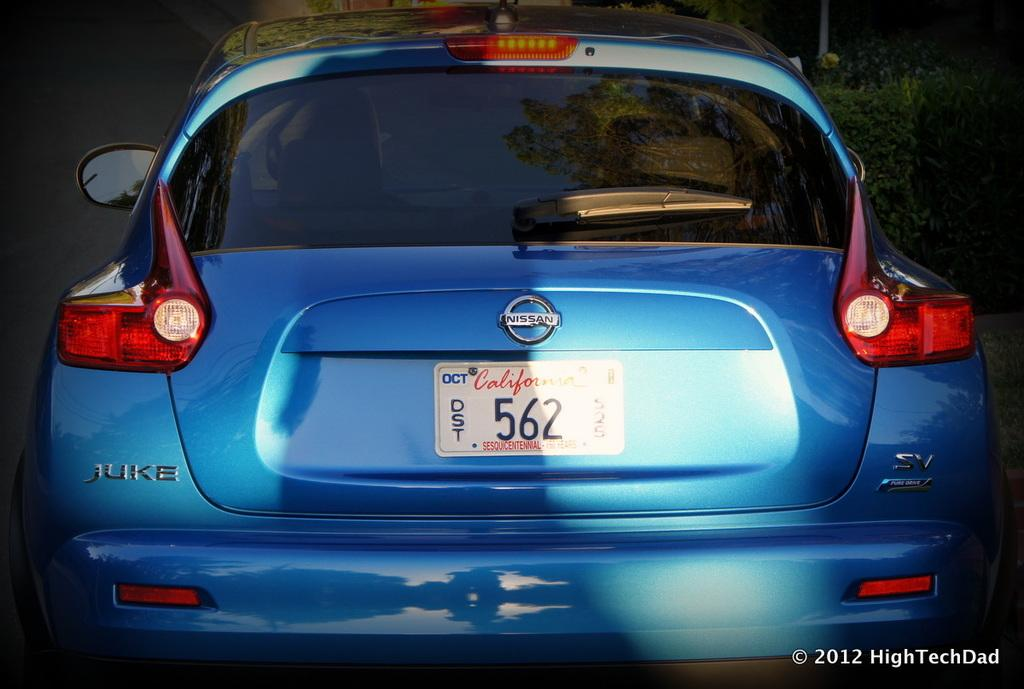<image>
Write a terse but informative summary of the picture. A blue car has a California number plate with the number 562 